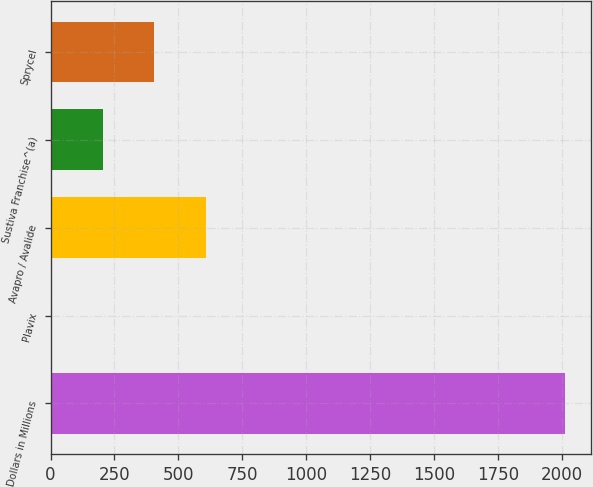Convert chart to OTSL. <chart><loc_0><loc_0><loc_500><loc_500><bar_chart><fcel>Dollars in Millions<fcel>Plavix<fcel>Avapro / Avalide<fcel>Sustiva Franchise^(a)<fcel>Sprycel<nl><fcel>2011<fcel>5<fcel>606.8<fcel>205.6<fcel>406.2<nl></chart> 